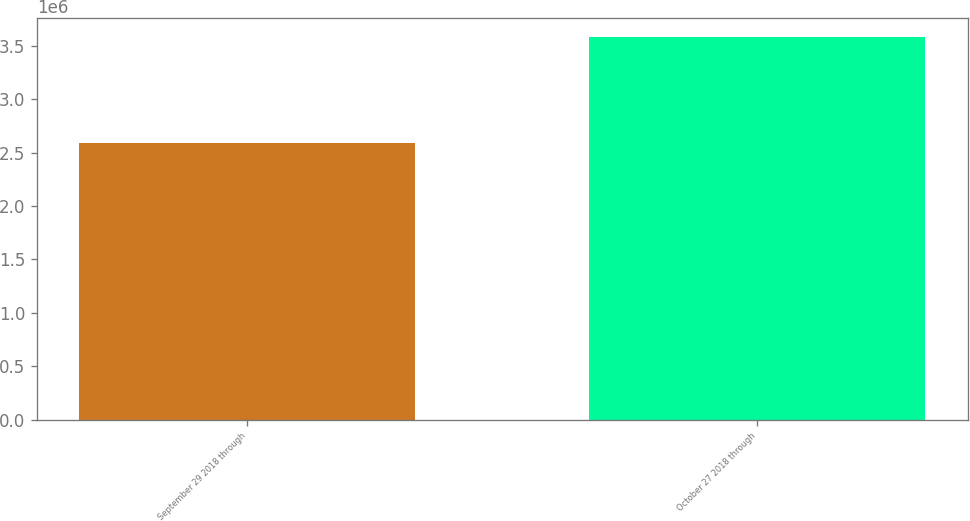Convert chart to OTSL. <chart><loc_0><loc_0><loc_500><loc_500><bar_chart><fcel>September 29 2018 through<fcel>October 27 2018 through<nl><fcel>2.5848e+06<fcel>3.5842e+06<nl></chart> 